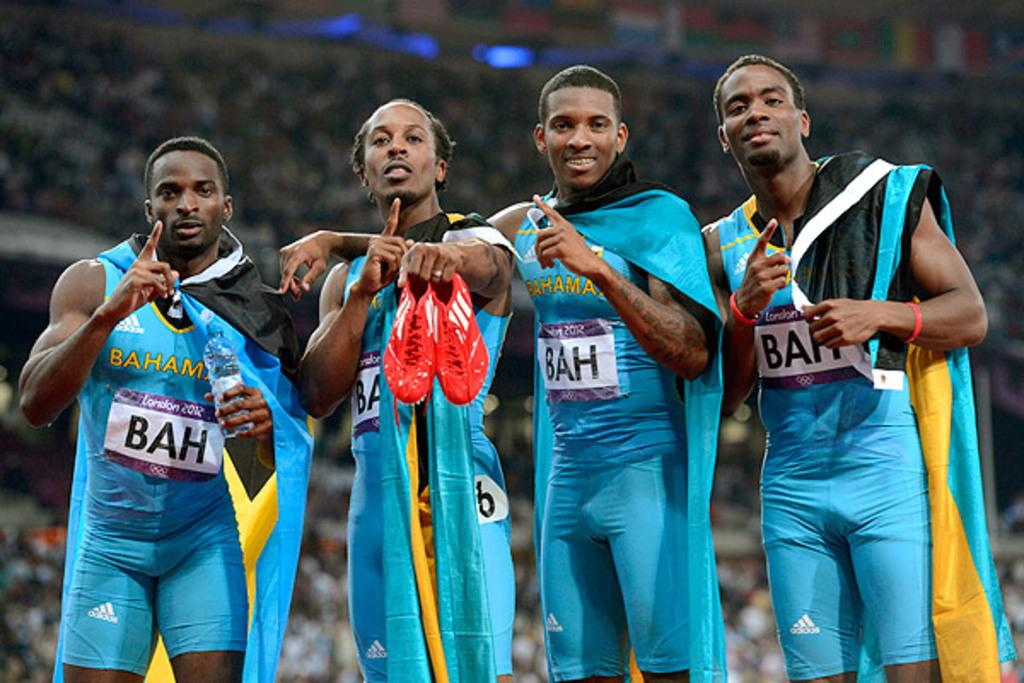Provide a one-sentence caption for the provided image. Olympic athletes from the Bahamas with their country's flag over their shoulders pose for a photograph. 